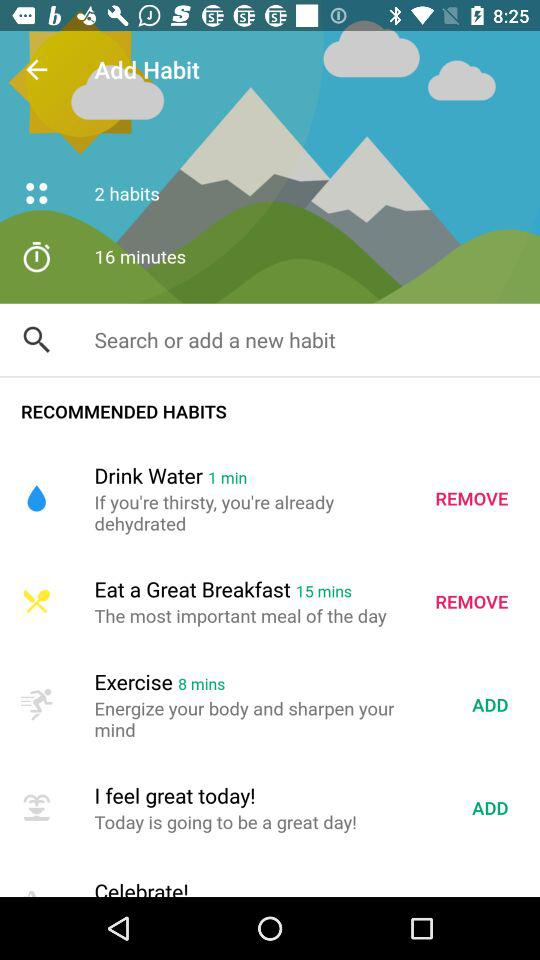Which habit takes 8 minutes to complete? The habit is "Exercise". 